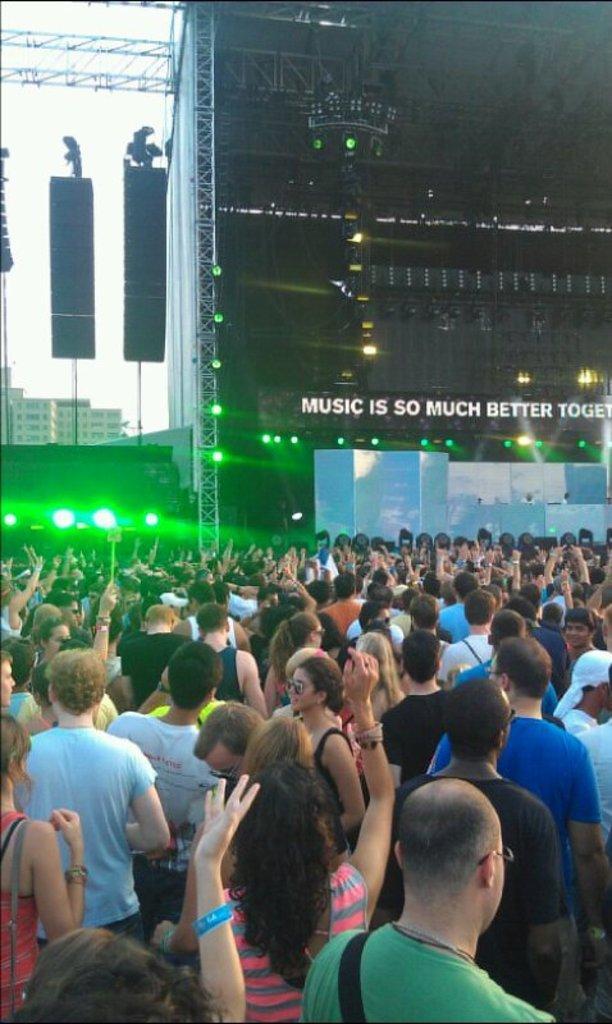Describe this image in one or two sentences. In this picture we can see groups of people standing on the path and in front of the people there is a stage with lights and behind the stage there are buildings and a sky. 